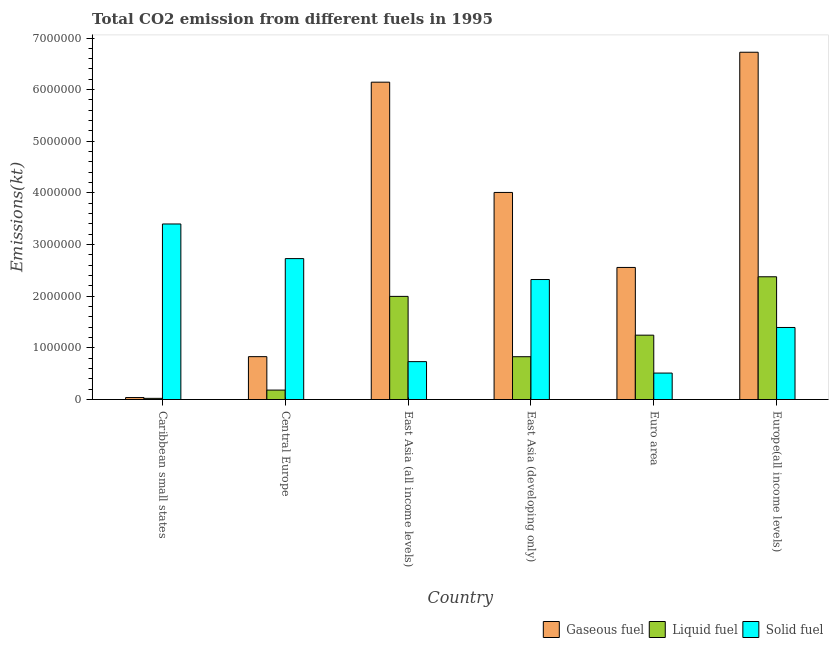How many different coloured bars are there?
Your response must be concise. 3. How many groups of bars are there?
Give a very brief answer. 6. Are the number of bars on each tick of the X-axis equal?
Keep it short and to the point. Yes. How many bars are there on the 6th tick from the left?
Make the answer very short. 3. In how many cases, is the number of bars for a given country not equal to the number of legend labels?
Your answer should be compact. 0. What is the amount of co2 emissions from gaseous fuel in Europe(all income levels)?
Give a very brief answer. 6.72e+06. Across all countries, what is the maximum amount of co2 emissions from gaseous fuel?
Make the answer very short. 6.72e+06. Across all countries, what is the minimum amount of co2 emissions from gaseous fuel?
Keep it short and to the point. 3.83e+04. In which country was the amount of co2 emissions from liquid fuel maximum?
Your response must be concise. Europe(all income levels). In which country was the amount of co2 emissions from solid fuel minimum?
Your response must be concise. Euro area. What is the total amount of co2 emissions from liquid fuel in the graph?
Your answer should be very brief. 6.65e+06. What is the difference between the amount of co2 emissions from gaseous fuel in Caribbean small states and that in Euro area?
Offer a terse response. -2.52e+06. What is the difference between the amount of co2 emissions from solid fuel in Caribbean small states and the amount of co2 emissions from liquid fuel in Central Europe?
Give a very brief answer. 3.22e+06. What is the average amount of co2 emissions from gaseous fuel per country?
Provide a succinct answer. 3.38e+06. What is the difference between the amount of co2 emissions from gaseous fuel and amount of co2 emissions from liquid fuel in East Asia (all income levels)?
Your response must be concise. 4.15e+06. In how many countries, is the amount of co2 emissions from gaseous fuel greater than 1400000 kt?
Your answer should be very brief. 4. What is the ratio of the amount of co2 emissions from solid fuel in Caribbean small states to that in Euro area?
Offer a terse response. 6.64. Is the amount of co2 emissions from gaseous fuel in Central Europe less than that in Europe(all income levels)?
Your response must be concise. Yes. Is the difference between the amount of co2 emissions from liquid fuel in Caribbean small states and East Asia (all income levels) greater than the difference between the amount of co2 emissions from gaseous fuel in Caribbean small states and East Asia (all income levels)?
Offer a terse response. Yes. What is the difference between the highest and the second highest amount of co2 emissions from solid fuel?
Keep it short and to the point. 6.70e+05. What is the difference between the highest and the lowest amount of co2 emissions from gaseous fuel?
Your answer should be compact. 6.69e+06. What does the 3rd bar from the left in East Asia (developing only) represents?
Ensure brevity in your answer.  Solid fuel. What does the 2nd bar from the right in East Asia (developing only) represents?
Make the answer very short. Liquid fuel. Is it the case that in every country, the sum of the amount of co2 emissions from gaseous fuel and amount of co2 emissions from liquid fuel is greater than the amount of co2 emissions from solid fuel?
Ensure brevity in your answer.  No. How many bars are there?
Your response must be concise. 18. Are all the bars in the graph horizontal?
Give a very brief answer. No. How many countries are there in the graph?
Provide a succinct answer. 6. Are the values on the major ticks of Y-axis written in scientific E-notation?
Make the answer very short. No. What is the title of the graph?
Keep it short and to the point. Total CO2 emission from different fuels in 1995. Does "Communicable diseases" appear as one of the legend labels in the graph?
Your answer should be very brief. No. What is the label or title of the X-axis?
Your answer should be very brief. Country. What is the label or title of the Y-axis?
Provide a succinct answer. Emissions(kt). What is the Emissions(kt) of Gaseous fuel in Caribbean small states?
Provide a succinct answer. 3.83e+04. What is the Emissions(kt) of Liquid fuel in Caribbean small states?
Your answer should be compact. 2.26e+04. What is the Emissions(kt) of Solid fuel in Caribbean small states?
Your answer should be very brief. 3.40e+06. What is the Emissions(kt) of Gaseous fuel in Central Europe?
Offer a terse response. 8.30e+05. What is the Emissions(kt) in Liquid fuel in Central Europe?
Your answer should be very brief. 1.83e+05. What is the Emissions(kt) of Solid fuel in Central Europe?
Your answer should be very brief. 2.73e+06. What is the Emissions(kt) of Gaseous fuel in East Asia (all income levels)?
Provide a succinct answer. 6.14e+06. What is the Emissions(kt) of Liquid fuel in East Asia (all income levels)?
Offer a very short reply. 2.00e+06. What is the Emissions(kt) of Solid fuel in East Asia (all income levels)?
Ensure brevity in your answer.  7.33e+05. What is the Emissions(kt) in Gaseous fuel in East Asia (developing only)?
Your response must be concise. 4.01e+06. What is the Emissions(kt) in Liquid fuel in East Asia (developing only)?
Give a very brief answer. 8.29e+05. What is the Emissions(kt) of Solid fuel in East Asia (developing only)?
Provide a succinct answer. 2.32e+06. What is the Emissions(kt) in Gaseous fuel in Euro area?
Provide a short and direct response. 2.56e+06. What is the Emissions(kt) of Liquid fuel in Euro area?
Ensure brevity in your answer.  1.25e+06. What is the Emissions(kt) of Solid fuel in Euro area?
Offer a very short reply. 5.12e+05. What is the Emissions(kt) of Gaseous fuel in Europe(all income levels)?
Ensure brevity in your answer.  6.72e+06. What is the Emissions(kt) in Liquid fuel in Europe(all income levels)?
Provide a succinct answer. 2.38e+06. What is the Emissions(kt) of Solid fuel in Europe(all income levels)?
Make the answer very short. 1.39e+06. Across all countries, what is the maximum Emissions(kt) in Gaseous fuel?
Ensure brevity in your answer.  6.72e+06. Across all countries, what is the maximum Emissions(kt) in Liquid fuel?
Make the answer very short. 2.38e+06. Across all countries, what is the maximum Emissions(kt) in Solid fuel?
Offer a terse response. 3.40e+06. Across all countries, what is the minimum Emissions(kt) in Gaseous fuel?
Provide a succinct answer. 3.83e+04. Across all countries, what is the minimum Emissions(kt) in Liquid fuel?
Offer a very short reply. 2.26e+04. Across all countries, what is the minimum Emissions(kt) of Solid fuel?
Your answer should be compact. 5.12e+05. What is the total Emissions(kt) of Gaseous fuel in the graph?
Provide a short and direct response. 2.03e+07. What is the total Emissions(kt) in Liquid fuel in the graph?
Your answer should be very brief. 6.65e+06. What is the total Emissions(kt) in Solid fuel in the graph?
Your response must be concise. 1.11e+07. What is the difference between the Emissions(kt) of Gaseous fuel in Caribbean small states and that in Central Europe?
Offer a terse response. -7.92e+05. What is the difference between the Emissions(kt) of Liquid fuel in Caribbean small states and that in Central Europe?
Ensure brevity in your answer.  -1.60e+05. What is the difference between the Emissions(kt) of Solid fuel in Caribbean small states and that in Central Europe?
Provide a succinct answer. 6.70e+05. What is the difference between the Emissions(kt) in Gaseous fuel in Caribbean small states and that in East Asia (all income levels)?
Offer a terse response. -6.11e+06. What is the difference between the Emissions(kt) of Liquid fuel in Caribbean small states and that in East Asia (all income levels)?
Make the answer very short. -1.97e+06. What is the difference between the Emissions(kt) of Solid fuel in Caribbean small states and that in East Asia (all income levels)?
Your answer should be compact. 2.67e+06. What is the difference between the Emissions(kt) of Gaseous fuel in Caribbean small states and that in East Asia (developing only)?
Ensure brevity in your answer.  -3.97e+06. What is the difference between the Emissions(kt) in Liquid fuel in Caribbean small states and that in East Asia (developing only)?
Offer a very short reply. -8.06e+05. What is the difference between the Emissions(kt) in Solid fuel in Caribbean small states and that in East Asia (developing only)?
Offer a very short reply. 1.08e+06. What is the difference between the Emissions(kt) in Gaseous fuel in Caribbean small states and that in Euro area?
Offer a terse response. -2.52e+06. What is the difference between the Emissions(kt) of Liquid fuel in Caribbean small states and that in Euro area?
Your response must be concise. -1.22e+06. What is the difference between the Emissions(kt) of Solid fuel in Caribbean small states and that in Euro area?
Make the answer very short. 2.89e+06. What is the difference between the Emissions(kt) in Gaseous fuel in Caribbean small states and that in Europe(all income levels)?
Offer a very short reply. -6.69e+06. What is the difference between the Emissions(kt) in Liquid fuel in Caribbean small states and that in Europe(all income levels)?
Provide a succinct answer. -2.35e+06. What is the difference between the Emissions(kt) of Solid fuel in Caribbean small states and that in Europe(all income levels)?
Your response must be concise. 2.00e+06. What is the difference between the Emissions(kt) in Gaseous fuel in Central Europe and that in East Asia (all income levels)?
Provide a succinct answer. -5.31e+06. What is the difference between the Emissions(kt) of Liquid fuel in Central Europe and that in East Asia (all income levels)?
Keep it short and to the point. -1.81e+06. What is the difference between the Emissions(kt) in Solid fuel in Central Europe and that in East Asia (all income levels)?
Ensure brevity in your answer.  2.00e+06. What is the difference between the Emissions(kt) of Gaseous fuel in Central Europe and that in East Asia (developing only)?
Your answer should be compact. -3.18e+06. What is the difference between the Emissions(kt) in Liquid fuel in Central Europe and that in East Asia (developing only)?
Keep it short and to the point. -6.46e+05. What is the difference between the Emissions(kt) in Solid fuel in Central Europe and that in East Asia (developing only)?
Your answer should be very brief. 4.05e+05. What is the difference between the Emissions(kt) of Gaseous fuel in Central Europe and that in Euro area?
Provide a short and direct response. -1.73e+06. What is the difference between the Emissions(kt) in Liquid fuel in Central Europe and that in Euro area?
Your response must be concise. -1.06e+06. What is the difference between the Emissions(kt) in Solid fuel in Central Europe and that in Euro area?
Make the answer very short. 2.22e+06. What is the difference between the Emissions(kt) in Gaseous fuel in Central Europe and that in Europe(all income levels)?
Give a very brief answer. -5.89e+06. What is the difference between the Emissions(kt) in Liquid fuel in Central Europe and that in Europe(all income levels)?
Your response must be concise. -2.19e+06. What is the difference between the Emissions(kt) of Solid fuel in Central Europe and that in Europe(all income levels)?
Make the answer very short. 1.33e+06. What is the difference between the Emissions(kt) in Gaseous fuel in East Asia (all income levels) and that in East Asia (developing only)?
Keep it short and to the point. 2.14e+06. What is the difference between the Emissions(kt) of Liquid fuel in East Asia (all income levels) and that in East Asia (developing only)?
Provide a short and direct response. 1.17e+06. What is the difference between the Emissions(kt) of Solid fuel in East Asia (all income levels) and that in East Asia (developing only)?
Offer a very short reply. -1.59e+06. What is the difference between the Emissions(kt) of Gaseous fuel in East Asia (all income levels) and that in Euro area?
Your answer should be very brief. 3.59e+06. What is the difference between the Emissions(kt) of Liquid fuel in East Asia (all income levels) and that in Euro area?
Offer a terse response. 7.51e+05. What is the difference between the Emissions(kt) of Solid fuel in East Asia (all income levels) and that in Euro area?
Provide a succinct answer. 2.21e+05. What is the difference between the Emissions(kt) of Gaseous fuel in East Asia (all income levels) and that in Europe(all income levels)?
Provide a short and direct response. -5.80e+05. What is the difference between the Emissions(kt) of Liquid fuel in East Asia (all income levels) and that in Europe(all income levels)?
Make the answer very short. -3.80e+05. What is the difference between the Emissions(kt) of Solid fuel in East Asia (all income levels) and that in Europe(all income levels)?
Your answer should be compact. -6.62e+05. What is the difference between the Emissions(kt) in Gaseous fuel in East Asia (developing only) and that in Euro area?
Make the answer very short. 1.45e+06. What is the difference between the Emissions(kt) in Liquid fuel in East Asia (developing only) and that in Euro area?
Offer a very short reply. -4.17e+05. What is the difference between the Emissions(kt) in Solid fuel in East Asia (developing only) and that in Euro area?
Offer a terse response. 1.81e+06. What is the difference between the Emissions(kt) in Gaseous fuel in East Asia (developing only) and that in Europe(all income levels)?
Offer a terse response. -2.71e+06. What is the difference between the Emissions(kt) in Liquid fuel in East Asia (developing only) and that in Europe(all income levels)?
Offer a terse response. -1.55e+06. What is the difference between the Emissions(kt) of Solid fuel in East Asia (developing only) and that in Europe(all income levels)?
Offer a very short reply. 9.29e+05. What is the difference between the Emissions(kt) of Gaseous fuel in Euro area and that in Europe(all income levels)?
Give a very brief answer. -4.17e+06. What is the difference between the Emissions(kt) of Liquid fuel in Euro area and that in Europe(all income levels)?
Offer a very short reply. -1.13e+06. What is the difference between the Emissions(kt) in Solid fuel in Euro area and that in Europe(all income levels)?
Provide a short and direct response. -8.83e+05. What is the difference between the Emissions(kt) in Gaseous fuel in Caribbean small states and the Emissions(kt) in Liquid fuel in Central Europe?
Your answer should be very brief. -1.44e+05. What is the difference between the Emissions(kt) of Gaseous fuel in Caribbean small states and the Emissions(kt) of Solid fuel in Central Europe?
Offer a terse response. -2.69e+06. What is the difference between the Emissions(kt) in Liquid fuel in Caribbean small states and the Emissions(kt) in Solid fuel in Central Europe?
Offer a very short reply. -2.71e+06. What is the difference between the Emissions(kt) in Gaseous fuel in Caribbean small states and the Emissions(kt) in Liquid fuel in East Asia (all income levels)?
Ensure brevity in your answer.  -1.96e+06. What is the difference between the Emissions(kt) of Gaseous fuel in Caribbean small states and the Emissions(kt) of Solid fuel in East Asia (all income levels)?
Offer a very short reply. -6.95e+05. What is the difference between the Emissions(kt) in Liquid fuel in Caribbean small states and the Emissions(kt) in Solid fuel in East Asia (all income levels)?
Ensure brevity in your answer.  -7.11e+05. What is the difference between the Emissions(kt) in Gaseous fuel in Caribbean small states and the Emissions(kt) in Liquid fuel in East Asia (developing only)?
Offer a terse response. -7.91e+05. What is the difference between the Emissions(kt) in Gaseous fuel in Caribbean small states and the Emissions(kt) in Solid fuel in East Asia (developing only)?
Ensure brevity in your answer.  -2.29e+06. What is the difference between the Emissions(kt) in Liquid fuel in Caribbean small states and the Emissions(kt) in Solid fuel in East Asia (developing only)?
Keep it short and to the point. -2.30e+06. What is the difference between the Emissions(kt) in Gaseous fuel in Caribbean small states and the Emissions(kt) in Liquid fuel in Euro area?
Provide a succinct answer. -1.21e+06. What is the difference between the Emissions(kt) of Gaseous fuel in Caribbean small states and the Emissions(kt) of Solid fuel in Euro area?
Your answer should be very brief. -4.74e+05. What is the difference between the Emissions(kt) in Liquid fuel in Caribbean small states and the Emissions(kt) in Solid fuel in Euro area?
Offer a very short reply. -4.90e+05. What is the difference between the Emissions(kt) in Gaseous fuel in Caribbean small states and the Emissions(kt) in Liquid fuel in Europe(all income levels)?
Give a very brief answer. -2.34e+06. What is the difference between the Emissions(kt) of Gaseous fuel in Caribbean small states and the Emissions(kt) of Solid fuel in Europe(all income levels)?
Provide a short and direct response. -1.36e+06. What is the difference between the Emissions(kt) of Liquid fuel in Caribbean small states and the Emissions(kt) of Solid fuel in Europe(all income levels)?
Offer a terse response. -1.37e+06. What is the difference between the Emissions(kt) in Gaseous fuel in Central Europe and the Emissions(kt) in Liquid fuel in East Asia (all income levels)?
Provide a succinct answer. -1.17e+06. What is the difference between the Emissions(kt) of Gaseous fuel in Central Europe and the Emissions(kt) of Solid fuel in East Asia (all income levels)?
Provide a short and direct response. 9.66e+04. What is the difference between the Emissions(kt) of Liquid fuel in Central Europe and the Emissions(kt) of Solid fuel in East Asia (all income levels)?
Your answer should be compact. -5.51e+05. What is the difference between the Emissions(kt) of Gaseous fuel in Central Europe and the Emissions(kt) of Liquid fuel in East Asia (developing only)?
Ensure brevity in your answer.  1182.78. What is the difference between the Emissions(kt) of Gaseous fuel in Central Europe and the Emissions(kt) of Solid fuel in East Asia (developing only)?
Provide a succinct answer. -1.49e+06. What is the difference between the Emissions(kt) of Liquid fuel in Central Europe and the Emissions(kt) of Solid fuel in East Asia (developing only)?
Your answer should be very brief. -2.14e+06. What is the difference between the Emissions(kt) in Gaseous fuel in Central Europe and the Emissions(kt) in Liquid fuel in Euro area?
Provide a short and direct response. -4.16e+05. What is the difference between the Emissions(kt) of Gaseous fuel in Central Europe and the Emissions(kt) of Solid fuel in Euro area?
Keep it short and to the point. 3.18e+05. What is the difference between the Emissions(kt) in Liquid fuel in Central Europe and the Emissions(kt) in Solid fuel in Euro area?
Offer a very short reply. -3.30e+05. What is the difference between the Emissions(kt) in Gaseous fuel in Central Europe and the Emissions(kt) in Liquid fuel in Europe(all income levels)?
Offer a very short reply. -1.55e+06. What is the difference between the Emissions(kt) of Gaseous fuel in Central Europe and the Emissions(kt) of Solid fuel in Europe(all income levels)?
Offer a terse response. -5.65e+05. What is the difference between the Emissions(kt) of Liquid fuel in Central Europe and the Emissions(kt) of Solid fuel in Europe(all income levels)?
Your response must be concise. -1.21e+06. What is the difference between the Emissions(kt) in Gaseous fuel in East Asia (all income levels) and the Emissions(kt) in Liquid fuel in East Asia (developing only)?
Offer a very short reply. 5.32e+06. What is the difference between the Emissions(kt) in Gaseous fuel in East Asia (all income levels) and the Emissions(kt) in Solid fuel in East Asia (developing only)?
Give a very brief answer. 3.82e+06. What is the difference between the Emissions(kt) of Liquid fuel in East Asia (all income levels) and the Emissions(kt) of Solid fuel in East Asia (developing only)?
Your response must be concise. -3.26e+05. What is the difference between the Emissions(kt) in Gaseous fuel in East Asia (all income levels) and the Emissions(kt) in Liquid fuel in Euro area?
Offer a very short reply. 4.90e+06. What is the difference between the Emissions(kt) in Gaseous fuel in East Asia (all income levels) and the Emissions(kt) in Solid fuel in Euro area?
Your answer should be compact. 5.63e+06. What is the difference between the Emissions(kt) in Liquid fuel in East Asia (all income levels) and the Emissions(kt) in Solid fuel in Euro area?
Keep it short and to the point. 1.48e+06. What is the difference between the Emissions(kt) in Gaseous fuel in East Asia (all income levels) and the Emissions(kt) in Liquid fuel in Europe(all income levels)?
Provide a succinct answer. 3.77e+06. What is the difference between the Emissions(kt) of Gaseous fuel in East Asia (all income levels) and the Emissions(kt) of Solid fuel in Europe(all income levels)?
Your response must be concise. 4.75e+06. What is the difference between the Emissions(kt) in Liquid fuel in East Asia (all income levels) and the Emissions(kt) in Solid fuel in Europe(all income levels)?
Your answer should be very brief. 6.02e+05. What is the difference between the Emissions(kt) of Gaseous fuel in East Asia (developing only) and the Emissions(kt) of Liquid fuel in Euro area?
Your response must be concise. 2.76e+06. What is the difference between the Emissions(kt) in Gaseous fuel in East Asia (developing only) and the Emissions(kt) in Solid fuel in Euro area?
Offer a very short reply. 3.50e+06. What is the difference between the Emissions(kt) of Liquid fuel in East Asia (developing only) and the Emissions(kt) of Solid fuel in Euro area?
Offer a terse response. 3.17e+05. What is the difference between the Emissions(kt) of Gaseous fuel in East Asia (developing only) and the Emissions(kt) of Liquid fuel in Europe(all income levels)?
Your answer should be very brief. 1.63e+06. What is the difference between the Emissions(kt) of Gaseous fuel in East Asia (developing only) and the Emissions(kt) of Solid fuel in Europe(all income levels)?
Your response must be concise. 2.61e+06. What is the difference between the Emissions(kt) in Liquid fuel in East Asia (developing only) and the Emissions(kt) in Solid fuel in Europe(all income levels)?
Offer a very short reply. -5.66e+05. What is the difference between the Emissions(kt) in Gaseous fuel in Euro area and the Emissions(kt) in Liquid fuel in Europe(all income levels)?
Provide a succinct answer. 1.81e+05. What is the difference between the Emissions(kt) in Gaseous fuel in Euro area and the Emissions(kt) in Solid fuel in Europe(all income levels)?
Your answer should be compact. 1.16e+06. What is the difference between the Emissions(kt) of Liquid fuel in Euro area and the Emissions(kt) of Solid fuel in Europe(all income levels)?
Keep it short and to the point. -1.49e+05. What is the average Emissions(kt) of Gaseous fuel per country?
Ensure brevity in your answer.  3.38e+06. What is the average Emissions(kt) of Liquid fuel per country?
Your answer should be very brief. 1.11e+06. What is the average Emissions(kt) in Solid fuel per country?
Provide a succinct answer. 1.85e+06. What is the difference between the Emissions(kt) in Gaseous fuel and Emissions(kt) in Liquid fuel in Caribbean small states?
Ensure brevity in your answer.  1.57e+04. What is the difference between the Emissions(kt) in Gaseous fuel and Emissions(kt) in Solid fuel in Caribbean small states?
Make the answer very short. -3.36e+06. What is the difference between the Emissions(kt) of Liquid fuel and Emissions(kt) of Solid fuel in Caribbean small states?
Provide a succinct answer. -3.38e+06. What is the difference between the Emissions(kt) in Gaseous fuel and Emissions(kt) in Liquid fuel in Central Europe?
Give a very brief answer. 6.47e+05. What is the difference between the Emissions(kt) in Gaseous fuel and Emissions(kt) in Solid fuel in Central Europe?
Give a very brief answer. -1.90e+06. What is the difference between the Emissions(kt) of Liquid fuel and Emissions(kt) of Solid fuel in Central Europe?
Ensure brevity in your answer.  -2.55e+06. What is the difference between the Emissions(kt) of Gaseous fuel and Emissions(kt) of Liquid fuel in East Asia (all income levels)?
Your response must be concise. 4.15e+06. What is the difference between the Emissions(kt) of Gaseous fuel and Emissions(kt) of Solid fuel in East Asia (all income levels)?
Offer a terse response. 5.41e+06. What is the difference between the Emissions(kt) of Liquid fuel and Emissions(kt) of Solid fuel in East Asia (all income levels)?
Give a very brief answer. 1.26e+06. What is the difference between the Emissions(kt) in Gaseous fuel and Emissions(kt) in Liquid fuel in East Asia (developing only)?
Make the answer very short. 3.18e+06. What is the difference between the Emissions(kt) in Gaseous fuel and Emissions(kt) in Solid fuel in East Asia (developing only)?
Provide a short and direct response. 1.69e+06. What is the difference between the Emissions(kt) in Liquid fuel and Emissions(kt) in Solid fuel in East Asia (developing only)?
Provide a succinct answer. -1.49e+06. What is the difference between the Emissions(kt) in Gaseous fuel and Emissions(kt) in Liquid fuel in Euro area?
Keep it short and to the point. 1.31e+06. What is the difference between the Emissions(kt) in Gaseous fuel and Emissions(kt) in Solid fuel in Euro area?
Your answer should be very brief. 2.05e+06. What is the difference between the Emissions(kt) in Liquid fuel and Emissions(kt) in Solid fuel in Euro area?
Ensure brevity in your answer.  7.34e+05. What is the difference between the Emissions(kt) of Gaseous fuel and Emissions(kt) of Liquid fuel in Europe(all income levels)?
Your answer should be very brief. 4.35e+06. What is the difference between the Emissions(kt) in Gaseous fuel and Emissions(kt) in Solid fuel in Europe(all income levels)?
Provide a short and direct response. 5.33e+06. What is the difference between the Emissions(kt) of Liquid fuel and Emissions(kt) of Solid fuel in Europe(all income levels)?
Give a very brief answer. 9.82e+05. What is the ratio of the Emissions(kt) of Gaseous fuel in Caribbean small states to that in Central Europe?
Provide a short and direct response. 0.05. What is the ratio of the Emissions(kt) in Liquid fuel in Caribbean small states to that in Central Europe?
Give a very brief answer. 0.12. What is the ratio of the Emissions(kt) of Solid fuel in Caribbean small states to that in Central Europe?
Provide a succinct answer. 1.25. What is the ratio of the Emissions(kt) in Gaseous fuel in Caribbean small states to that in East Asia (all income levels)?
Keep it short and to the point. 0.01. What is the ratio of the Emissions(kt) in Liquid fuel in Caribbean small states to that in East Asia (all income levels)?
Offer a very short reply. 0.01. What is the ratio of the Emissions(kt) of Solid fuel in Caribbean small states to that in East Asia (all income levels)?
Your answer should be very brief. 4.63. What is the ratio of the Emissions(kt) in Gaseous fuel in Caribbean small states to that in East Asia (developing only)?
Give a very brief answer. 0.01. What is the ratio of the Emissions(kt) in Liquid fuel in Caribbean small states to that in East Asia (developing only)?
Keep it short and to the point. 0.03. What is the ratio of the Emissions(kt) of Solid fuel in Caribbean small states to that in East Asia (developing only)?
Offer a terse response. 1.46. What is the ratio of the Emissions(kt) of Gaseous fuel in Caribbean small states to that in Euro area?
Offer a terse response. 0.01. What is the ratio of the Emissions(kt) in Liquid fuel in Caribbean small states to that in Euro area?
Give a very brief answer. 0.02. What is the ratio of the Emissions(kt) in Solid fuel in Caribbean small states to that in Euro area?
Your response must be concise. 6.64. What is the ratio of the Emissions(kt) of Gaseous fuel in Caribbean small states to that in Europe(all income levels)?
Your response must be concise. 0.01. What is the ratio of the Emissions(kt) in Liquid fuel in Caribbean small states to that in Europe(all income levels)?
Make the answer very short. 0.01. What is the ratio of the Emissions(kt) in Solid fuel in Caribbean small states to that in Europe(all income levels)?
Provide a succinct answer. 2.44. What is the ratio of the Emissions(kt) of Gaseous fuel in Central Europe to that in East Asia (all income levels)?
Your response must be concise. 0.14. What is the ratio of the Emissions(kt) in Liquid fuel in Central Europe to that in East Asia (all income levels)?
Provide a short and direct response. 0.09. What is the ratio of the Emissions(kt) of Solid fuel in Central Europe to that in East Asia (all income levels)?
Ensure brevity in your answer.  3.72. What is the ratio of the Emissions(kt) in Gaseous fuel in Central Europe to that in East Asia (developing only)?
Make the answer very short. 0.21. What is the ratio of the Emissions(kt) of Liquid fuel in Central Europe to that in East Asia (developing only)?
Provide a short and direct response. 0.22. What is the ratio of the Emissions(kt) in Solid fuel in Central Europe to that in East Asia (developing only)?
Make the answer very short. 1.17. What is the ratio of the Emissions(kt) in Gaseous fuel in Central Europe to that in Euro area?
Offer a terse response. 0.32. What is the ratio of the Emissions(kt) of Liquid fuel in Central Europe to that in Euro area?
Offer a terse response. 0.15. What is the ratio of the Emissions(kt) of Solid fuel in Central Europe to that in Euro area?
Offer a terse response. 5.33. What is the ratio of the Emissions(kt) in Gaseous fuel in Central Europe to that in Europe(all income levels)?
Make the answer very short. 0.12. What is the ratio of the Emissions(kt) of Liquid fuel in Central Europe to that in Europe(all income levels)?
Ensure brevity in your answer.  0.08. What is the ratio of the Emissions(kt) of Solid fuel in Central Europe to that in Europe(all income levels)?
Keep it short and to the point. 1.96. What is the ratio of the Emissions(kt) of Gaseous fuel in East Asia (all income levels) to that in East Asia (developing only)?
Offer a very short reply. 1.53. What is the ratio of the Emissions(kt) in Liquid fuel in East Asia (all income levels) to that in East Asia (developing only)?
Make the answer very short. 2.41. What is the ratio of the Emissions(kt) of Solid fuel in East Asia (all income levels) to that in East Asia (developing only)?
Ensure brevity in your answer.  0.32. What is the ratio of the Emissions(kt) of Gaseous fuel in East Asia (all income levels) to that in Euro area?
Your response must be concise. 2.4. What is the ratio of the Emissions(kt) of Liquid fuel in East Asia (all income levels) to that in Euro area?
Provide a short and direct response. 1.6. What is the ratio of the Emissions(kt) in Solid fuel in East Asia (all income levels) to that in Euro area?
Make the answer very short. 1.43. What is the ratio of the Emissions(kt) of Gaseous fuel in East Asia (all income levels) to that in Europe(all income levels)?
Your answer should be compact. 0.91. What is the ratio of the Emissions(kt) in Liquid fuel in East Asia (all income levels) to that in Europe(all income levels)?
Offer a terse response. 0.84. What is the ratio of the Emissions(kt) of Solid fuel in East Asia (all income levels) to that in Europe(all income levels)?
Make the answer very short. 0.53. What is the ratio of the Emissions(kt) of Gaseous fuel in East Asia (developing only) to that in Euro area?
Offer a very short reply. 1.57. What is the ratio of the Emissions(kt) of Liquid fuel in East Asia (developing only) to that in Euro area?
Offer a very short reply. 0.67. What is the ratio of the Emissions(kt) in Solid fuel in East Asia (developing only) to that in Euro area?
Keep it short and to the point. 4.54. What is the ratio of the Emissions(kt) in Gaseous fuel in East Asia (developing only) to that in Europe(all income levels)?
Give a very brief answer. 0.6. What is the ratio of the Emissions(kt) in Liquid fuel in East Asia (developing only) to that in Europe(all income levels)?
Provide a short and direct response. 0.35. What is the ratio of the Emissions(kt) in Solid fuel in East Asia (developing only) to that in Europe(all income levels)?
Make the answer very short. 1.67. What is the ratio of the Emissions(kt) of Gaseous fuel in Euro area to that in Europe(all income levels)?
Offer a terse response. 0.38. What is the ratio of the Emissions(kt) of Liquid fuel in Euro area to that in Europe(all income levels)?
Give a very brief answer. 0.52. What is the ratio of the Emissions(kt) of Solid fuel in Euro area to that in Europe(all income levels)?
Ensure brevity in your answer.  0.37. What is the difference between the highest and the second highest Emissions(kt) in Gaseous fuel?
Provide a short and direct response. 5.80e+05. What is the difference between the highest and the second highest Emissions(kt) in Liquid fuel?
Your answer should be compact. 3.80e+05. What is the difference between the highest and the second highest Emissions(kt) in Solid fuel?
Provide a short and direct response. 6.70e+05. What is the difference between the highest and the lowest Emissions(kt) of Gaseous fuel?
Give a very brief answer. 6.69e+06. What is the difference between the highest and the lowest Emissions(kt) in Liquid fuel?
Your answer should be very brief. 2.35e+06. What is the difference between the highest and the lowest Emissions(kt) of Solid fuel?
Offer a terse response. 2.89e+06. 